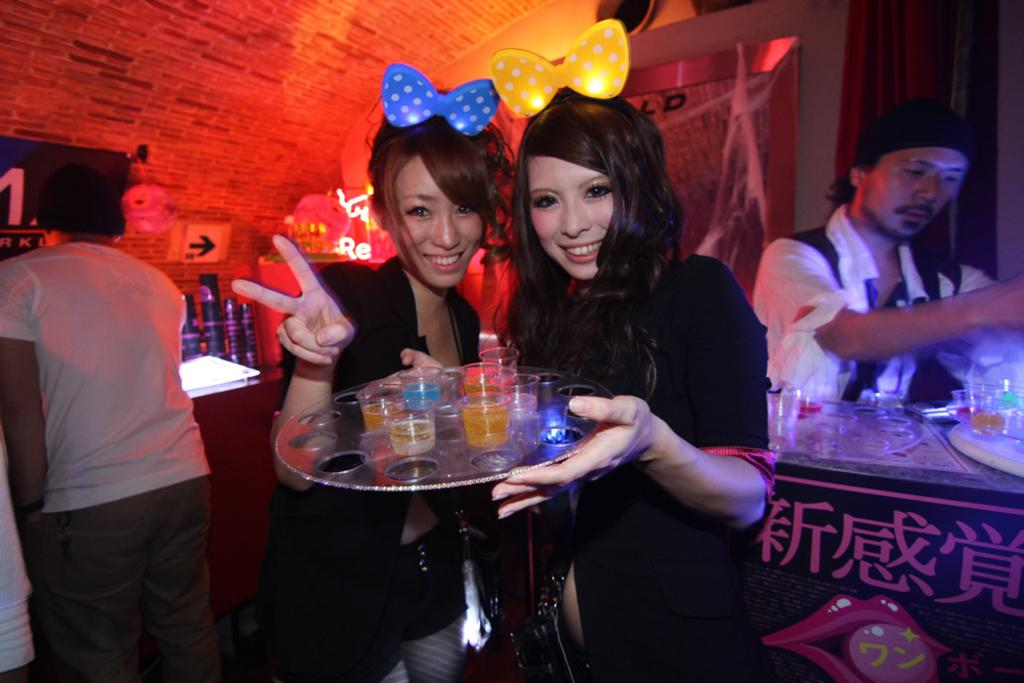How many people are in the image? There are people standing in the image, but the exact number is not specified. What is the person holding a tray carrying? The person holding a tray is carrying glasses on the tray. What can be seen in the background of the image? There are lights and objects visible in the background. Can you describe the objects present in the background? The provided facts do not specify the nature of the objects present in the background. What caption is written on the chair in the image? There is no chair or caption present in the image. What type of operation is being performed by the people in the image? The provided facts do not suggest any specific operation or activity being performed by the people in the image. 